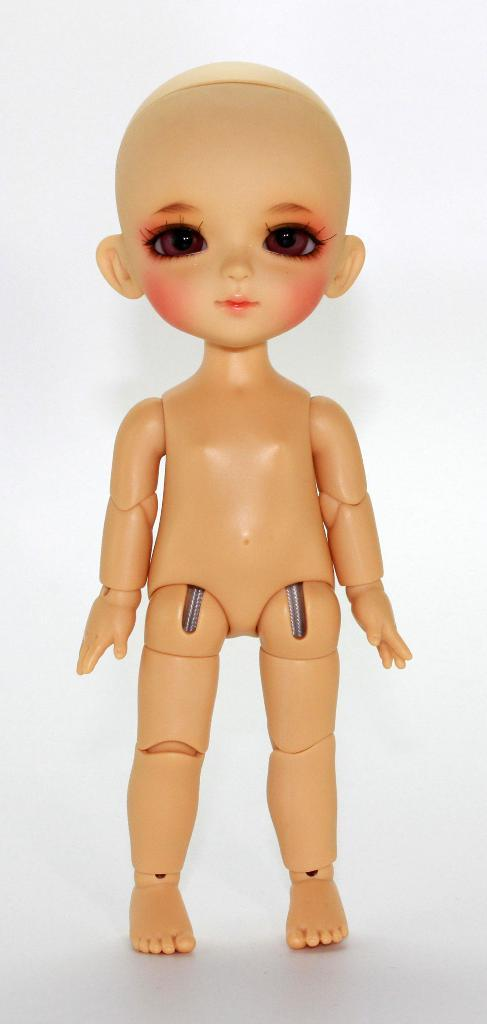What is the main subject in the center of the image? There is a doll in the center of the image. What color is the background of the image? The background of the image is white in color. What does the mom show to the donkey in the image? There is no mom or donkey present in the image; it only features a doll with a white background. 